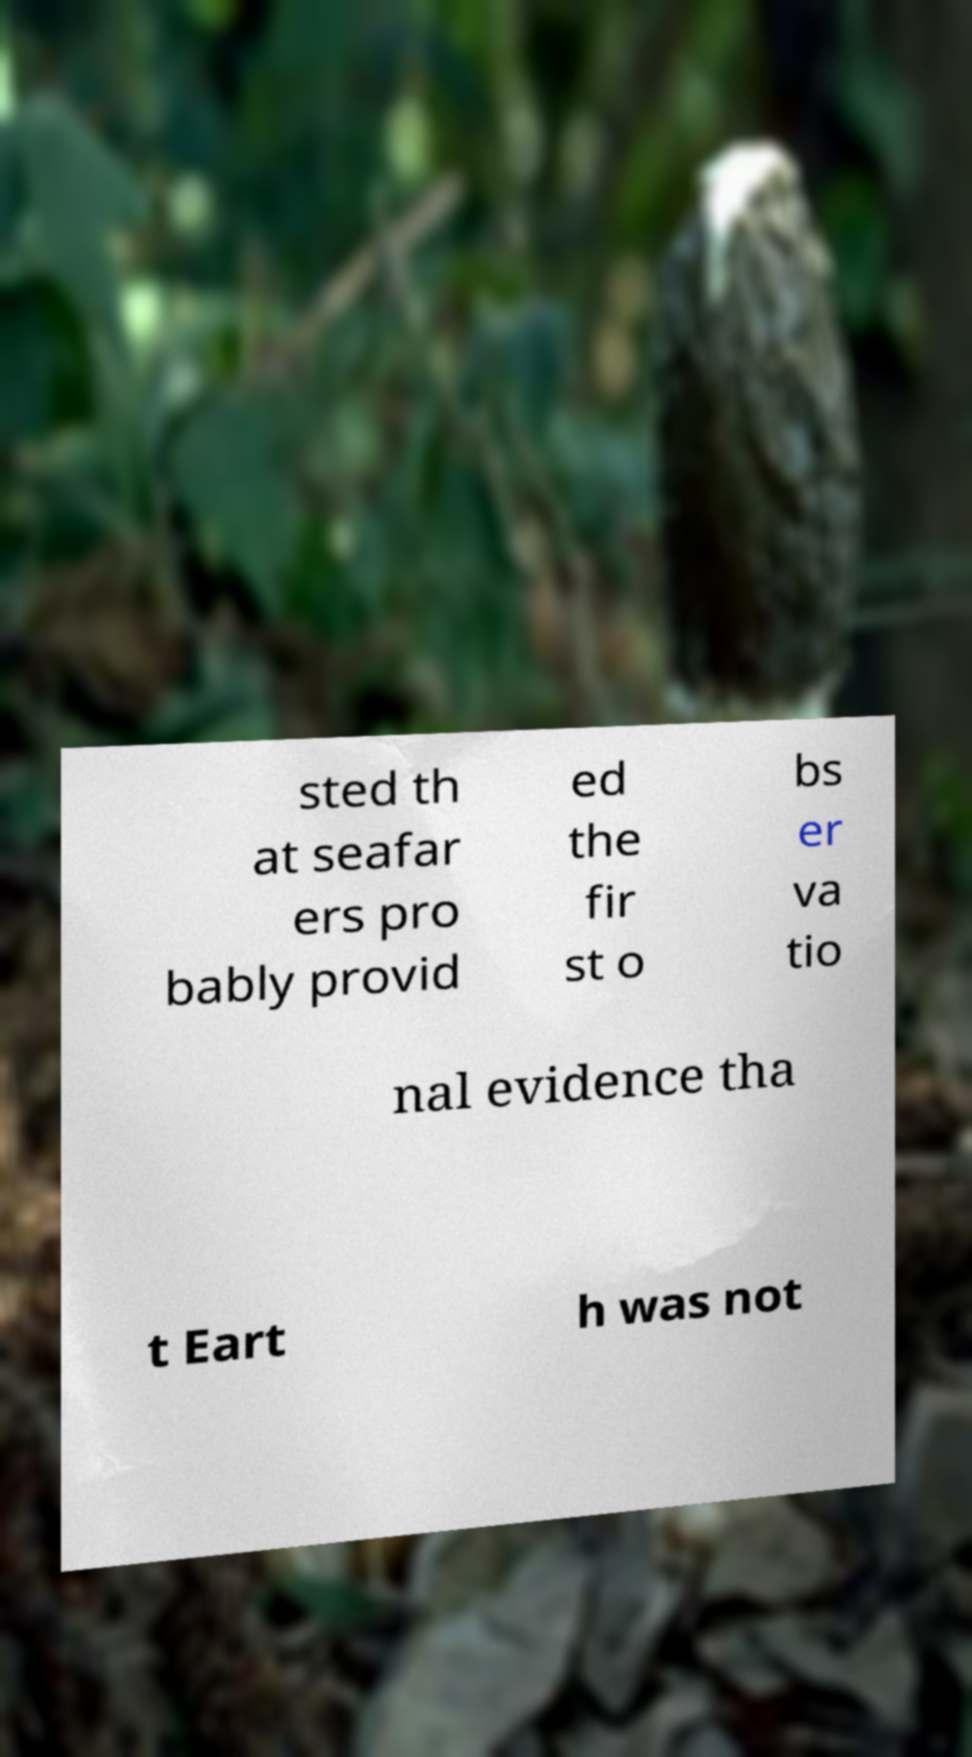Please identify and transcribe the text found in this image. sted th at seafar ers pro bably provid ed the fir st o bs er va tio nal evidence tha t Eart h was not 